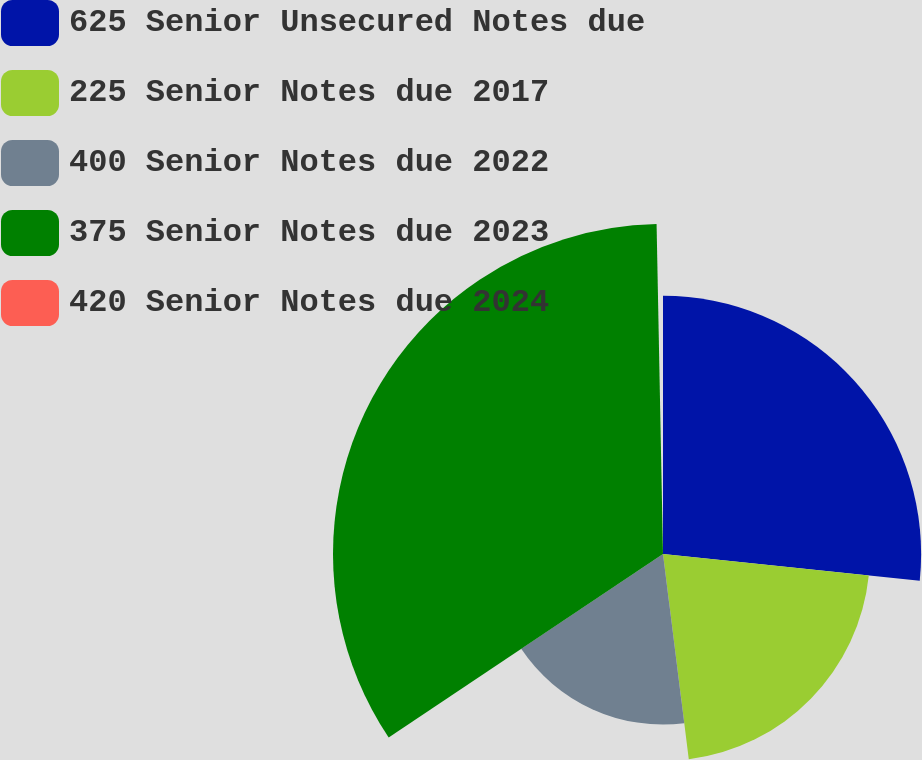<chart> <loc_0><loc_0><loc_500><loc_500><pie_chart><fcel>625 Senior Unsecured Notes due<fcel>225 Senior Notes due 2017<fcel>400 Senior Notes due 2022<fcel>375 Senior Notes due 2023<fcel>420 Senior Notes due 2024<nl><fcel>26.65%<fcel>21.36%<fcel>17.61%<fcel>34.07%<fcel>0.31%<nl></chart> 